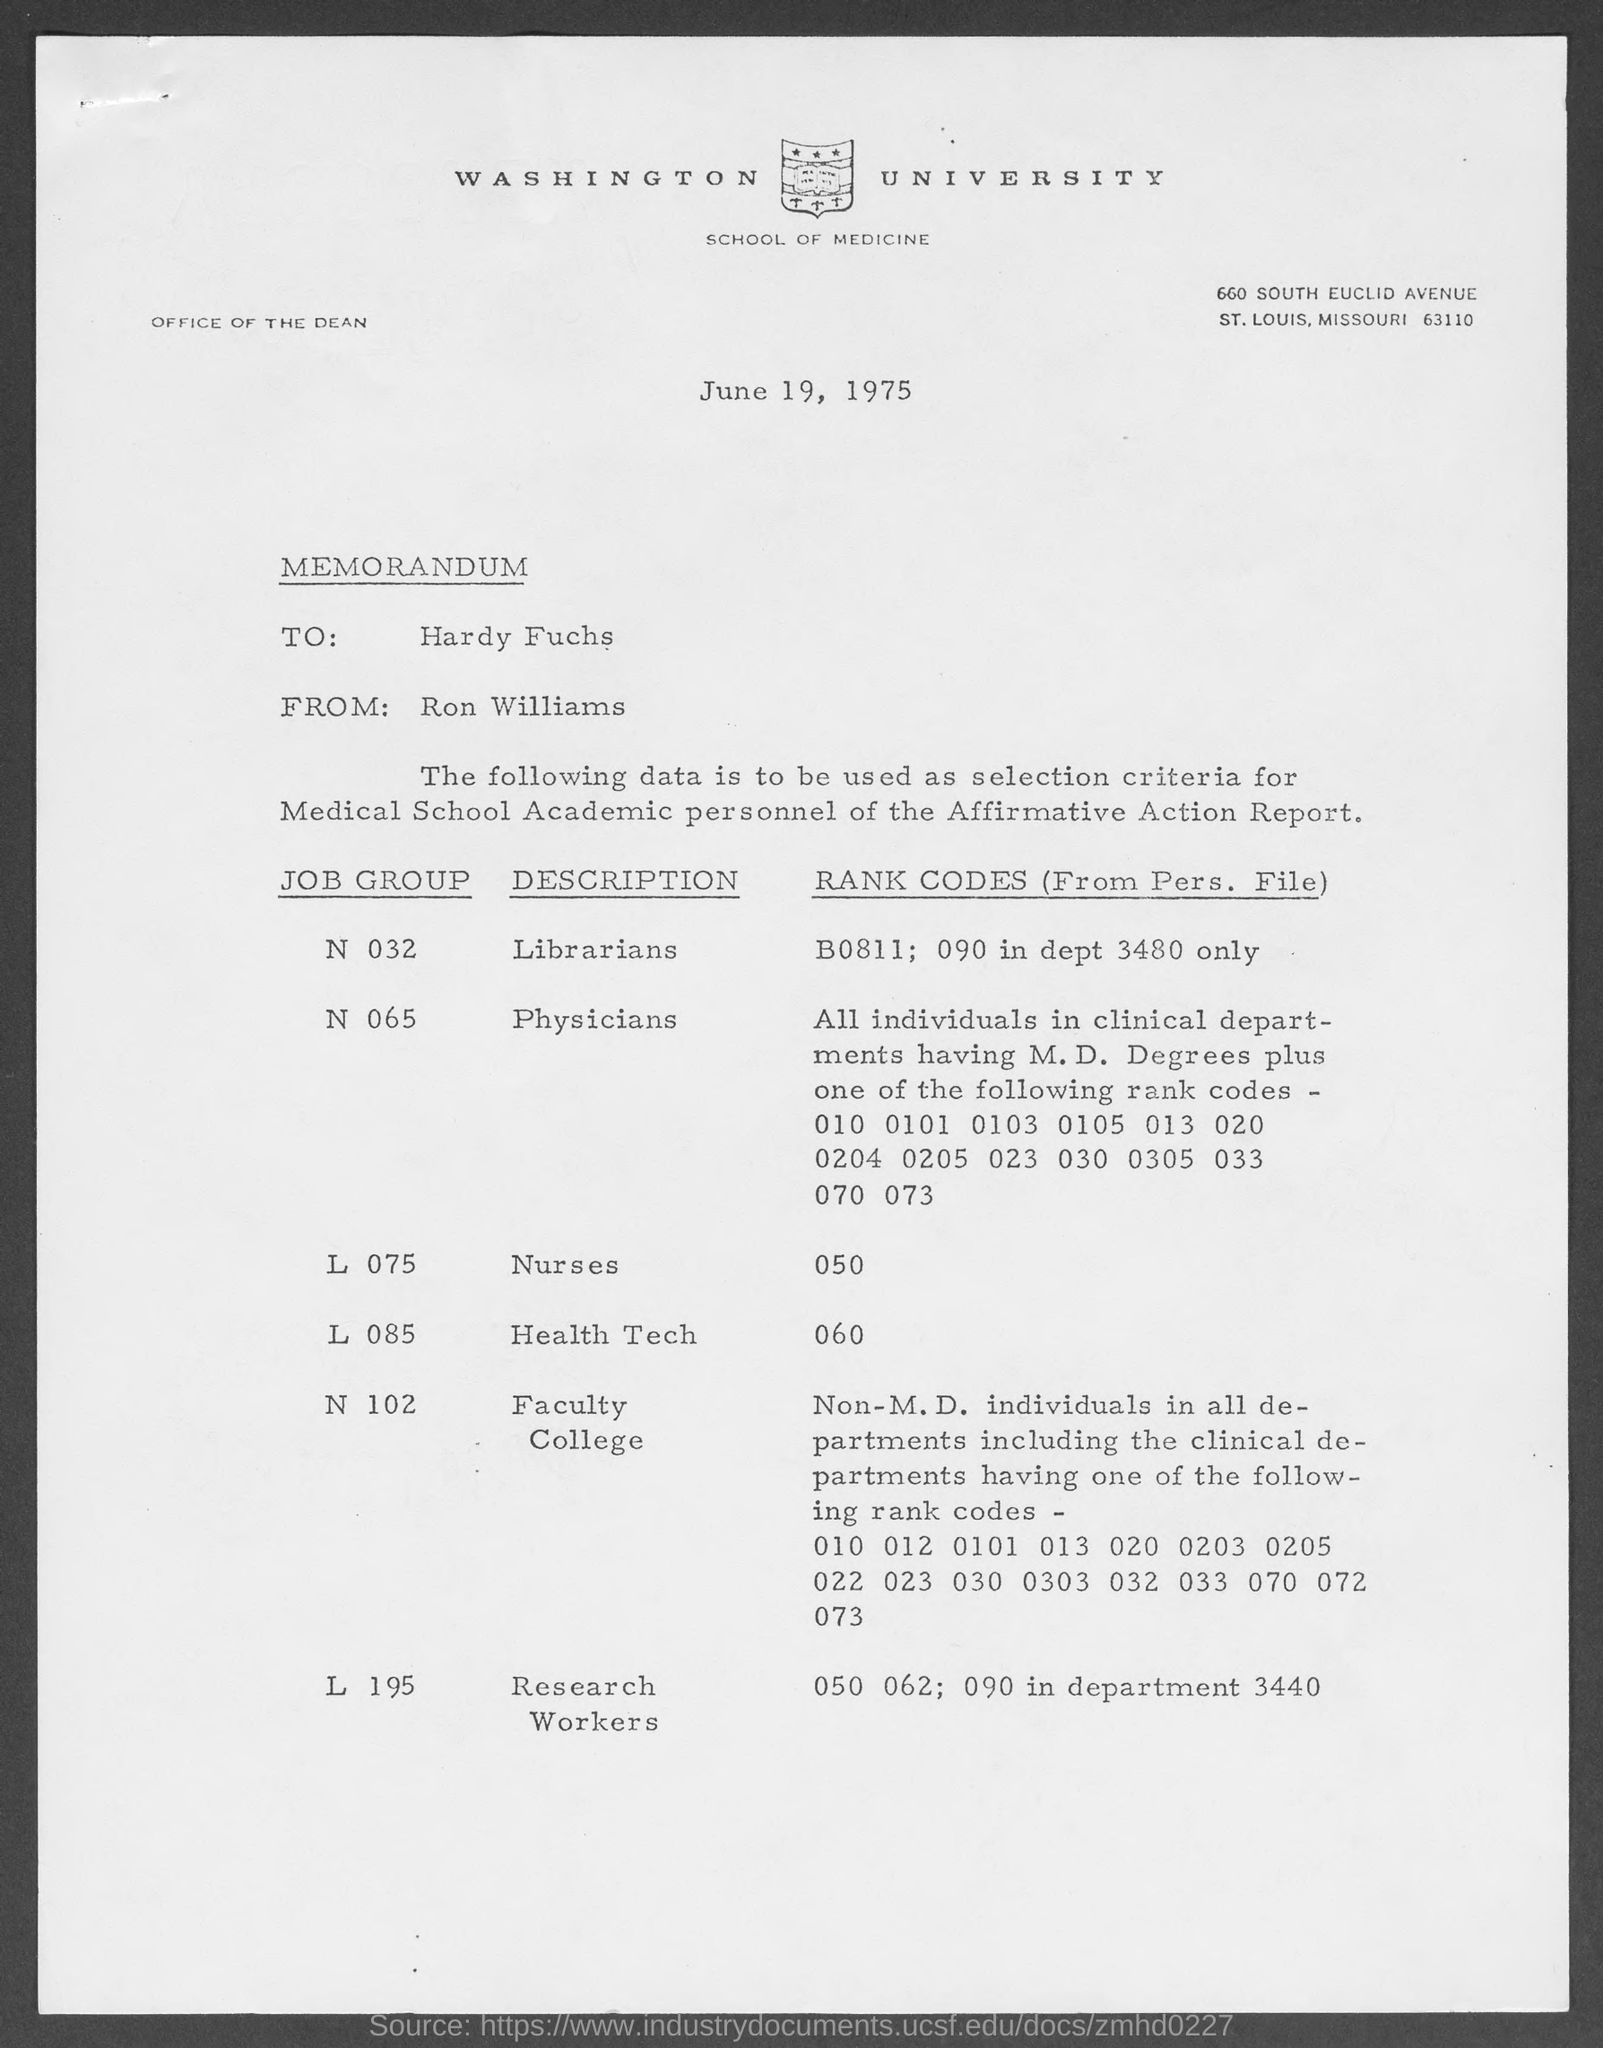What is the name of the avenue where washington university is at ?
Ensure brevity in your answer.  South Euclid Avenue. When is the memorandum dated?
Keep it short and to the point. June 19, 1975. To whom is this memorandum written to?
Provide a succinct answer. Hardy Fuchs. Whom is this memorandum from?
Provide a succinct answer. Ron Williams. What is the job group of librarians ?
Provide a short and direct response. N 032. What is the job group of physicians ?
Provide a short and direct response. N 065. What is the job group of nurses ?
Your answer should be very brief. L 075. What is the job group of health tech?
Provide a succinct answer. L 085. 